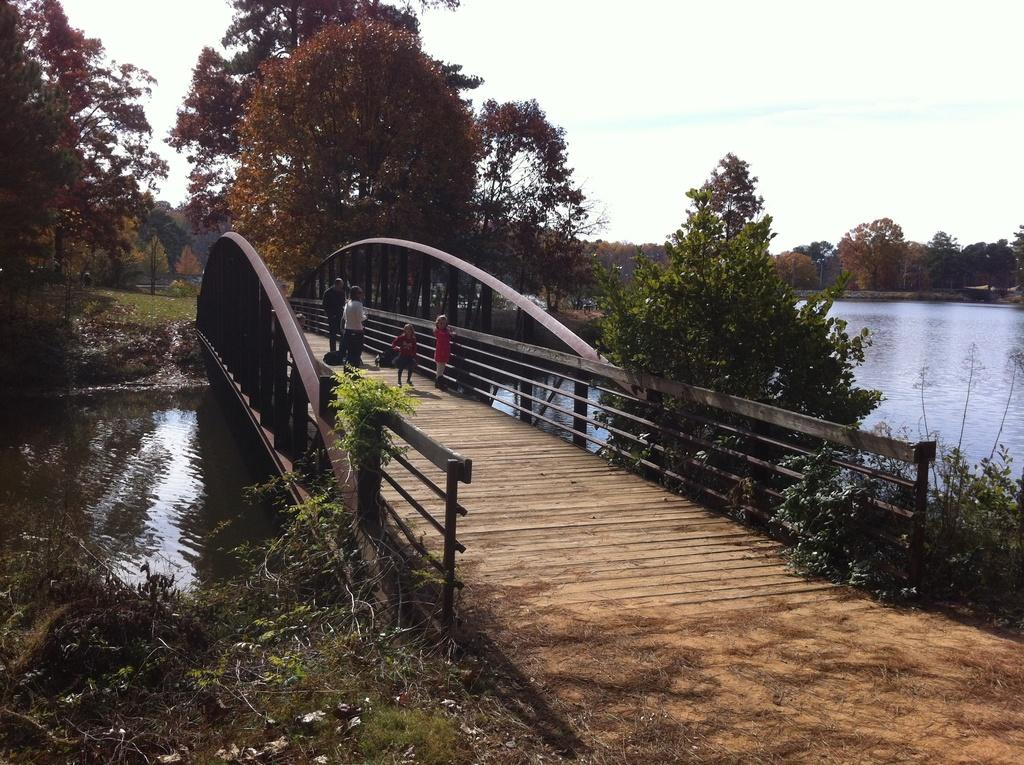What is the main structure in the center of the image? There is a dock in the center of the image. What is located beneath the dock? There is water under the dock. What type of vegetation can be seen around the area in the image? There is greenery around the area of the image. Are there any people present in the image? Yes, there are people on the dock. What type of rice is being cooked on the dock in the image? There is no rice present in the image, and no cooking activity is taking place on the dock. 